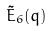Convert formula to latex. <formula><loc_0><loc_0><loc_500><loc_500>\tilde { E } _ { 6 } ( q )</formula> 